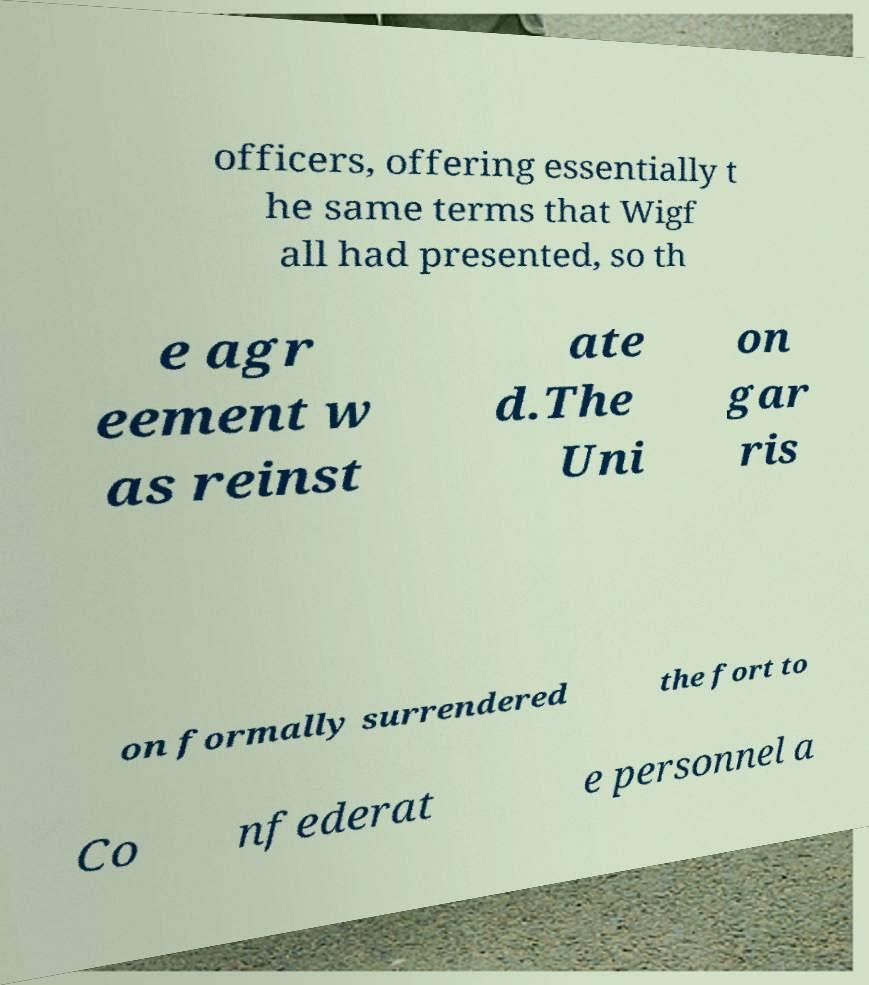There's text embedded in this image that I need extracted. Can you transcribe it verbatim? officers, offering essentially t he same terms that Wigf all had presented, so th e agr eement w as reinst ate d.The Uni on gar ris on formally surrendered the fort to Co nfederat e personnel a 